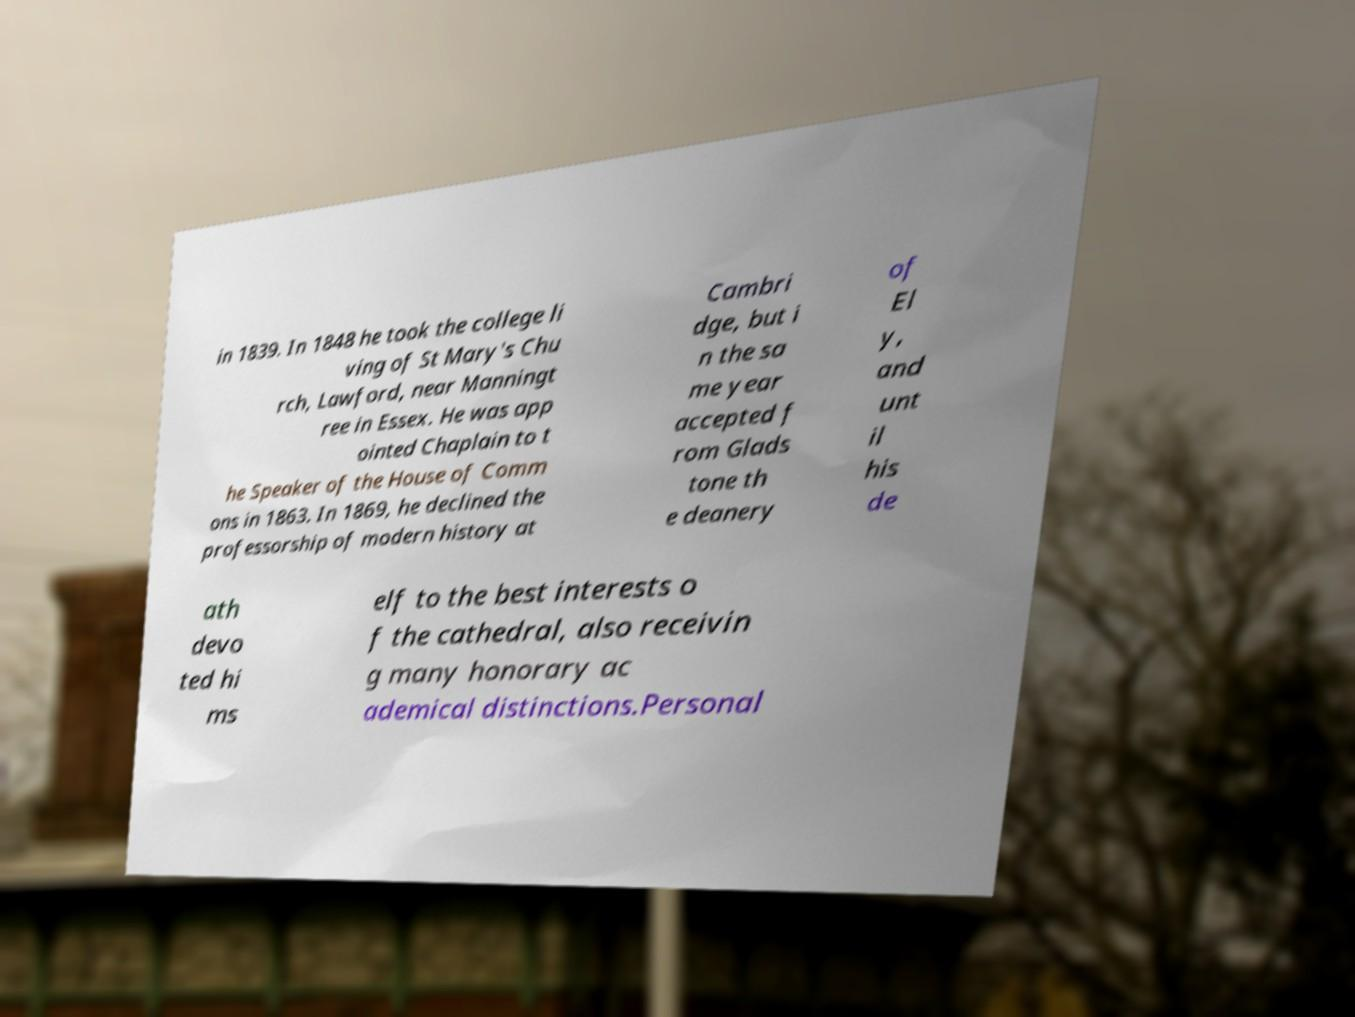I need the written content from this picture converted into text. Can you do that? in 1839. In 1848 he took the college li ving of St Mary's Chu rch, Lawford, near Manningt ree in Essex. He was app ointed Chaplain to t he Speaker of the House of Comm ons in 1863. In 1869, he declined the professorship of modern history at Cambri dge, but i n the sa me year accepted f rom Glads tone th e deanery of El y, and unt il his de ath devo ted hi ms elf to the best interests o f the cathedral, also receivin g many honorary ac ademical distinctions.Personal 